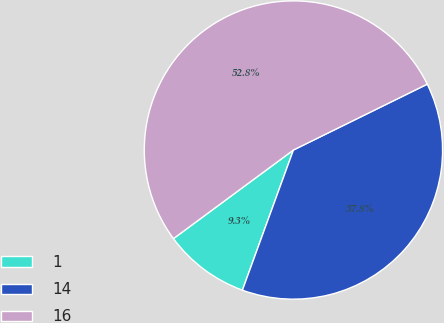Convert chart. <chart><loc_0><loc_0><loc_500><loc_500><pie_chart><fcel>1<fcel>14<fcel>16<nl><fcel>9.32%<fcel>37.83%<fcel>52.84%<nl></chart> 